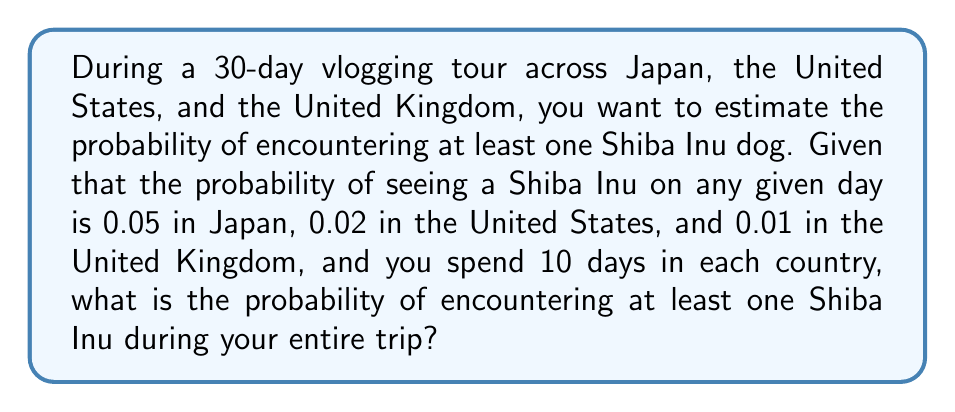What is the answer to this math problem? Let's approach this step-by-step:

1) First, we need to calculate the probability of not seeing a Shiba Inu on any given day in each country:
   - Japan: $1 - 0.05 = 0.95$
   - United States: $1 - 0.02 = 0.98$
   - United Kingdom: $1 - 0.01 = 0.99$

2) Now, we need to calculate the probability of not seeing a Shiba Inu for the entire duration in each country:
   - Japan: $0.95^{10} = 0.5987$
   - United States: $0.98^{10} = 0.8179$
   - United Kingdom: $0.99^{10} = 0.9043$

3) The probability of not seeing a Shiba Inu during the entire trip is the product of these probabilities:

   $$P(\text{no Shiba Inu}) = 0.5987 \times 0.8179 \times 0.9043 = 0.4437$$

4) Therefore, the probability of seeing at least one Shiba Inu during the trip is:

   $$P(\text{at least one Shiba Inu}) = 1 - P(\text{no Shiba Inu}) = 1 - 0.4437 = 0.5563$$

5) Converting to a percentage:

   $$0.5563 \times 100\% = 55.63\%$$
Answer: 55.63% 